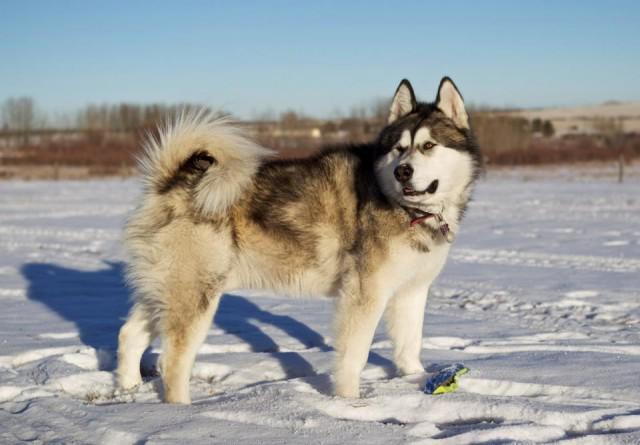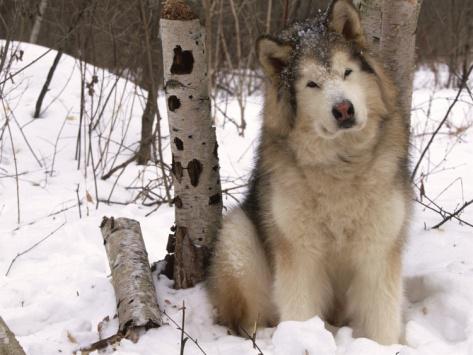The first image is the image on the left, the second image is the image on the right. Analyze the images presented: Is the assertion "One image shows a dog sitting upright on snow-covered ground, and the other image shows a forward-facing dog with snow mounded in front of it." valid? Answer yes or no. No. The first image is the image on the left, the second image is the image on the right. Given the left and right images, does the statement "The left and right image contains the same number of dogs with at least one standing in the snow." hold true? Answer yes or no. Yes. 